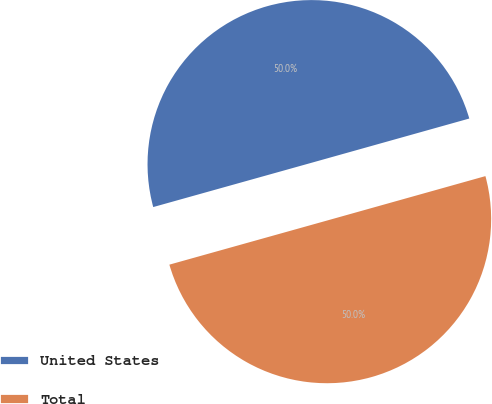Convert chart to OTSL. <chart><loc_0><loc_0><loc_500><loc_500><pie_chart><fcel>United States<fcel>Total<nl><fcel>49.99%<fcel>50.01%<nl></chart> 